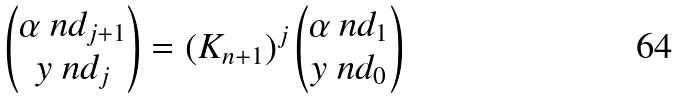Convert formula to latex. <formula><loc_0><loc_0><loc_500><loc_500>\begin{pmatrix} \alpha \ n d _ { j + 1 } \\ y \ n d _ { j } \end{pmatrix} = \left ( K _ { n + 1 } \right ) ^ { j } \begin{pmatrix} \alpha \ n d _ { 1 } \\ y \ n d _ { 0 } \end{pmatrix}</formula> 